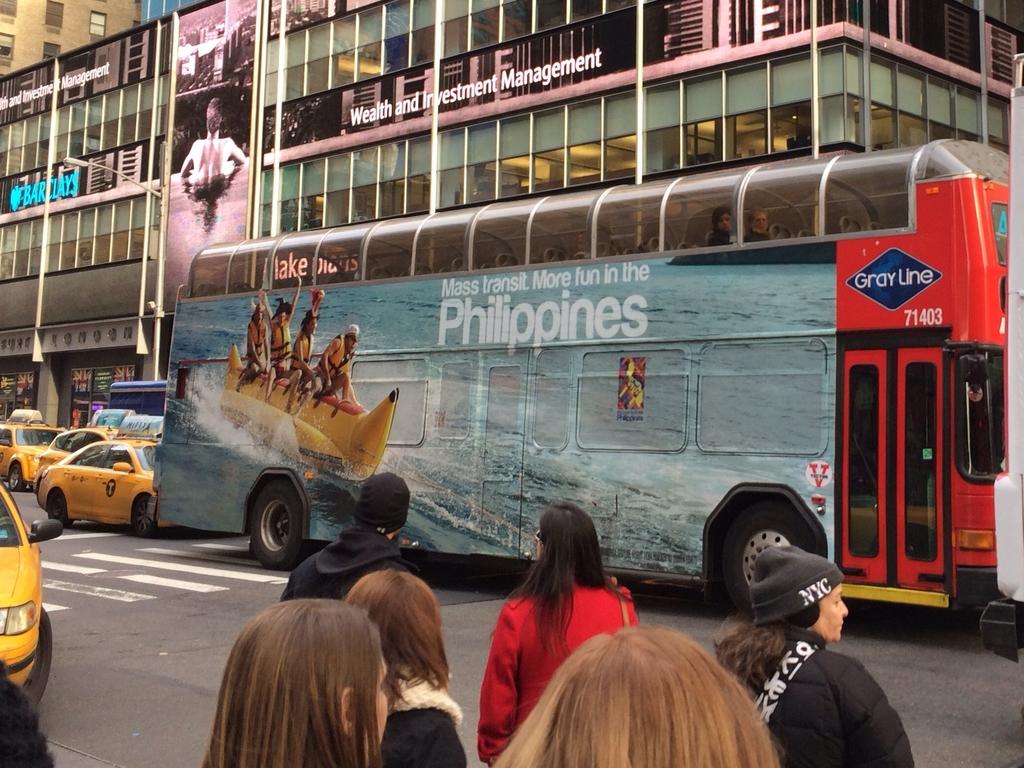What country is advertised here?
Offer a terse response. Philippines. What bank is advertised in the background?
Make the answer very short. Barclays. 